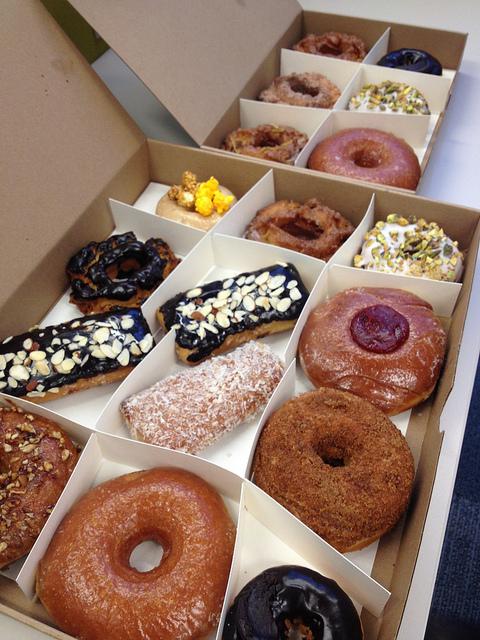What are the toppings on the pastries?
Concise answer only. Nuts. What pastries are these?
Keep it brief. Donuts. What is the box made of?
Keep it brief. Cardboard. 